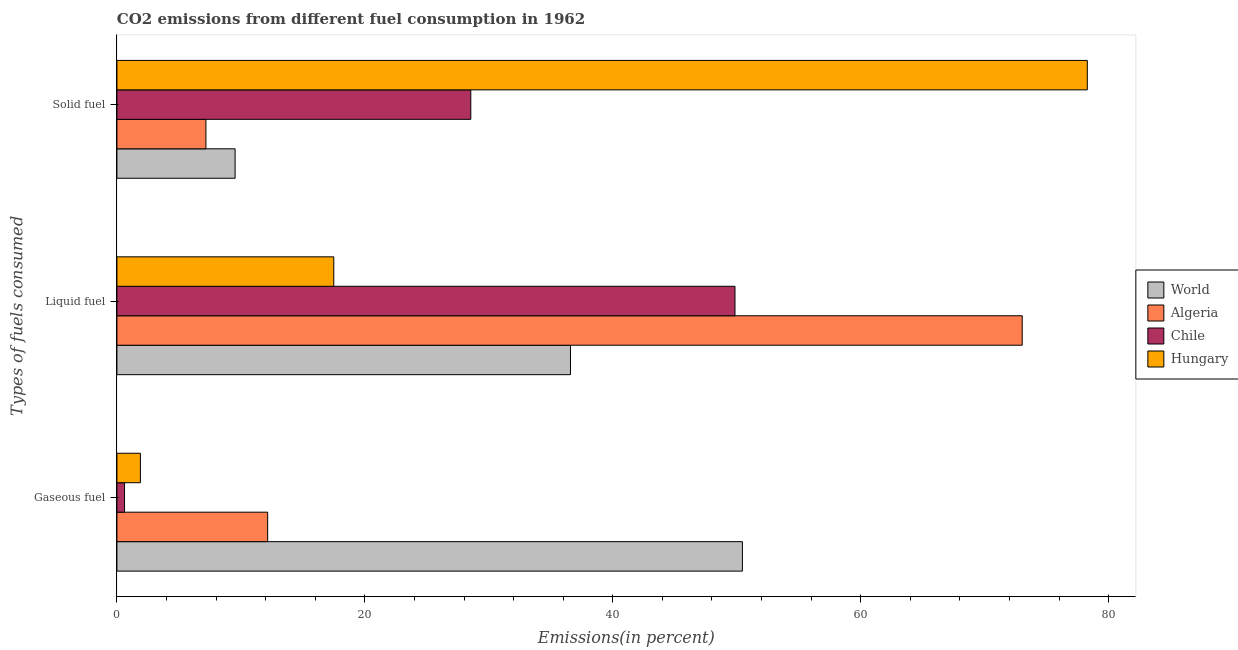Are the number of bars on each tick of the Y-axis equal?
Your response must be concise. Yes. How many bars are there on the 1st tick from the top?
Ensure brevity in your answer.  4. What is the label of the 2nd group of bars from the top?
Offer a terse response. Liquid fuel. What is the percentage of liquid fuel emission in World?
Your response must be concise. 36.59. Across all countries, what is the maximum percentage of gaseous fuel emission?
Provide a succinct answer. 50.46. Across all countries, what is the minimum percentage of liquid fuel emission?
Offer a terse response. 17.49. In which country was the percentage of solid fuel emission maximum?
Give a very brief answer. Hungary. In which country was the percentage of solid fuel emission minimum?
Your response must be concise. Algeria. What is the total percentage of gaseous fuel emission in the graph?
Your answer should be compact. 65.12. What is the difference between the percentage of solid fuel emission in Algeria and that in World?
Provide a short and direct response. -2.35. What is the difference between the percentage of gaseous fuel emission in Chile and the percentage of solid fuel emission in World?
Your response must be concise. -8.92. What is the average percentage of solid fuel emission per country?
Keep it short and to the point. 30.88. What is the difference between the percentage of gaseous fuel emission and percentage of solid fuel emission in Chile?
Make the answer very short. -27.93. What is the ratio of the percentage of solid fuel emission in World to that in Algeria?
Ensure brevity in your answer.  1.33. Is the difference between the percentage of gaseous fuel emission in Hungary and Chile greater than the difference between the percentage of solid fuel emission in Hungary and Chile?
Offer a terse response. No. What is the difference between the highest and the second highest percentage of solid fuel emission?
Your answer should be compact. 49.73. What is the difference between the highest and the lowest percentage of liquid fuel emission?
Give a very brief answer. 55.53. In how many countries, is the percentage of liquid fuel emission greater than the average percentage of liquid fuel emission taken over all countries?
Make the answer very short. 2. What does the 1st bar from the top in Gaseous fuel represents?
Make the answer very short. Hungary. What does the 2nd bar from the bottom in Gaseous fuel represents?
Your response must be concise. Algeria. How many bars are there?
Make the answer very short. 12. How many countries are there in the graph?
Your answer should be very brief. 4. What is the difference between two consecutive major ticks on the X-axis?
Ensure brevity in your answer.  20. Are the values on the major ticks of X-axis written in scientific E-notation?
Provide a short and direct response. No. How are the legend labels stacked?
Make the answer very short. Vertical. What is the title of the graph?
Keep it short and to the point. CO2 emissions from different fuel consumption in 1962. Does "Seychelles" appear as one of the legend labels in the graph?
Make the answer very short. No. What is the label or title of the X-axis?
Give a very brief answer. Emissions(in percent). What is the label or title of the Y-axis?
Keep it short and to the point. Types of fuels consumed. What is the Emissions(in percent) in World in Gaseous fuel?
Offer a terse response. 50.46. What is the Emissions(in percent) of Algeria in Gaseous fuel?
Provide a succinct answer. 12.16. What is the Emissions(in percent) of Chile in Gaseous fuel?
Keep it short and to the point. 0.61. What is the Emissions(in percent) in Hungary in Gaseous fuel?
Your answer should be very brief. 1.89. What is the Emissions(in percent) in World in Liquid fuel?
Your answer should be compact. 36.59. What is the Emissions(in percent) in Algeria in Liquid fuel?
Make the answer very short. 73.03. What is the Emissions(in percent) of Chile in Liquid fuel?
Your answer should be very brief. 49.86. What is the Emissions(in percent) in Hungary in Liquid fuel?
Offer a terse response. 17.49. What is the Emissions(in percent) of World in Solid fuel?
Ensure brevity in your answer.  9.53. What is the Emissions(in percent) of Algeria in Solid fuel?
Make the answer very short. 7.18. What is the Emissions(in percent) of Chile in Solid fuel?
Offer a terse response. 28.55. What is the Emissions(in percent) in Hungary in Solid fuel?
Your answer should be compact. 78.28. Across all Types of fuels consumed, what is the maximum Emissions(in percent) in World?
Offer a terse response. 50.46. Across all Types of fuels consumed, what is the maximum Emissions(in percent) of Algeria?
Your answer should be compact. 73.03. Across all Types of fuels consumed, what is the maximum Emissions(in percent) of Chile?
Your response must be concise. 49.86. Across all Types of fuels consumed, what is the maximum Emissions(in percent) in Hungary?
Offer a very short reply. 78.28. Across all Types of fuels consumed, what is the minimum Emissions(in percent) of World?
Provide a succinct answer. 9.53. Across all Types of fuels consumed, what is the minimum Emissions(in percent) of Algeria?
Your answer should be compact. 7.18. Across all Types of fuels consumed, what is the minimum Emissions(in percent) in Chile?
Offer a terse response. 0.61. Across all Types of fuels consumed, what is the minimum Emissions(in percent) in Hungary?
Provide a short and direct response. 1.89. What is the total Emissions(in percent) of World in the graph?
Your answer should be very brief. 96.58. What is the total Emissions(in percent) of Algeria in the graph?
Give a very brief answer. 92.37. What is the total Emissions(in percent) of Chile in the graph?
Your answer should be compact. 79.02. What is the total Emissions(in percent) in Hungary in the graph?
Ensure brevity in your answer.  97.66. What is the difference between the Emissions(in percent) in World in Gaseous fuel and that in Liquid fuel?
Offer a very short reply. 13.87. What is the difference between the Emissions(in percent) of Algeria in Gaseous fuel and that in Liquid fuel?
Keep it short and to the point. -60.87. What is the difference between the Emissions(in percent) of Chile in Gaseous fuel and that in Liquid fuel?
Ensure brevity in your answer.  -49.24. What is the difference between the Emissions(in percent) in Hungary in Gaseous fuel and that in Liquid fuel?
Provide a short and direct response. -15.6. What is the difference between the Emissions(in percent) in World in Gaseous fuel and that in Solid fuel?
Provide a short and direct response. 40.92. What is the difference between the Emissions(in percent) in Algeria in Gaseous fuel and that in Solid fuel?
Your answer should be compact. 4.98. What is the difference between the Emissions(in percent) in Chile in Gaseous fuel and that in Solid fuel?
Provide a succinct answer. -27.93. What is the difference between the Emissions(in percent) in Hungary in Gaseous fuel and that in Solid fuel?
Your answer should be compact. -76.39. What is the difference between the Emissions(in percent) in World in Liquid fuel and that in Solid fuel?
Give a very brief answer. 27.05. What is the difference between the Emissions(in percent) of Algeria in Liquid fuel and that in Solid fuel?
Keep it short and to the point. 65.85. What is the difference between the Emissions(in percent) of Chile in Liquid fuel and that in Solid fuel?
Your answer should be compact. 21.31. What is the difference between the Emissions(in percent) in Hungary in Liquid fuel and that in Solid fuel?
Your answer should be compact. -60.78. What is the difference between the Emissions(in percent) in World in Gaseous fuel and the Emissions(in percent) in Algeria in Liquid fuel?
Offer a very short reply. -22.57. What is the difference between the Emissions(in percent) of World in Gaseous fuel and the Emissions(in percent) of Chile in Liquid fuel?
Your answer should be very brief. 0.6. What is the difference between the Emissions(in percent) of World in Gaseous fuel and the Emissions(in percent) of Hungary in Liquid fuel?
Give a very brief answer. 32.96. What is the difference between the Emissions(in percent) of Algeria in Gaseous fuel and the Emissions(in percent) of Chile in Liquid fuel?
Ensure brevity in your answer.  -37.7. What is the difference between the Emissions(in percent) of Algeria in Gaseous fuel and the Emissions(in percent) of Hungary in Liquid fuel?
Your answer should be very brief. -5.33. What is the difference between the Emissions(in percent) of Chile in Gaseous fuel and the Emissions(in percent) of Hungary in Liquid fuel?
Provide a short and direct response. -16.88. What is the difference between the Emissions(in percent) of World in Gaseous fuel and the Emissions(in percent) of Algeria in Solid fuel?
Give a very brief answer. 43.28. What is the difference between the Emissions(in percent) in World in Gaseous fuel and the Emissions(in percent) in Chile in Solid fuel?
Offer a very short reply. 21.91. What is the difference between the Emissions(in percent) in World in Gaseous fuel and the Emissions(in percent) in Hungary in Solid fuel?
Ensure brevity in your answer.  -27.82. What is the difference between the Emissions(in percent) of Algeria in Gaseous fuel and the Emissions(in percent) of Chile in Solid fuel?
Ensure brevity in your answer.  -16.39. What is the difference between the Emissions(in percent) in Algeria in Gaseous fuel and the Emissions(in percent) in Hungary in Solid fuel?
Ensure brevity in your answer.  -66.12. What is the difference between the Emissions(in percent) in Chile in Gaseous fuel and the Emissions(in percent) in Hungary in Solid fuel?
Your answer should be compact. -77.66. What is the difference between the Emissions(in percent) of World in Liquid fuel and the Emissions(in percent) of Algeria in Solid fuel?
Give a very brief answer. 29.41. What is the difference between the Emissions(in percent) of World in Liquid fuel and the Emissions(in percent) of Chile in Solid fuel?
Your response must be concise. 8.04. What is the difference between the Emissions(in percent) of World in Liquid fuel and the Emissions(in percent) of Hungary in Solid fuel?
Make the answer very short. -41.69. What is the difference between the Emissions(in percent) of Algeria in Liquid fuel and the Emissions(in percent) of Chile in Solid fuel?
Provide a succinct answer. 44.48. What is the difference between the Emissions(in percent) in Algeria in Liquid fuel and the Emissions(in percent) in Hungary in Solid fuel?
Your answer should be compact. -5.25. What is the difference between the Emissions(in percent) in Chile in Liquid fuel and the Emissions(in percent) in Hungary in Solid fuel?
Make the answer very short. -28.42. What is the average Emissions(in percent) of World per Types of fuels consumed?
Make the answer very short. 32.19. What is the average Emissions(in percent) of Algeria per Types of fuels consumed?
Your response must be concise. 30.79. What is the average Emissions(in percent) of Chile per Types of fuels consumed?
Provide a short and direct response. 26.34. What is the average Emissions(in percent) in Hungary per Types of fuels consumed?
Give a very brief answer. 32.55. What is the difference between the Emissions(in percent) in World and Emissions(in percent) in Algeria in Gaseous fuel?
Make the answer very short. 38.29. What is the difference between the Emissions(in percent) in World and Emissions(in percent) in Chile in Gaseous fuel?
Make the answer very short. 49.84. What is the difference between the Emissions(in percent) of World and Emissions(in percent) of Hungary in Gaseous fuel?
Your answer should be very brief. 48.56. What is the difference between the Emissions(in percent) in Algeria and Emissions(in percent) in Chile in Gaseous fuel?
Your response must be concise. 11.55. What is the difference between the Emissions(in percent) in Algeria and Emissions(in percent) in Hungary in Gaseous fuel?
Give a very brief answer. 10.27. What is the difference between the Emissions(in percent) in Chile and Emissions(in percent) in Hungary in Gaseous fuel?
Offer a very short reply. -1.28. What is the difference between the Emissions(in percent) in World and Emissions(in percent) in Algeria in Liquid fuel?
Your answer should be very brief. -36.44. What is the difference between the Emissions(in percent) in World and Emissions(in percent) in Chile in Liquid fuel?
Keep it short and to the point. -13.27. What is the difference between the Emissions(in percent) in World and Emissions(in percent) in Hungary in Liquid fuel?
Your response must be concise. 19.09. What is the difference between the Emissions(in percent) in Algeria and Emissions(in percent) in Chile in Liquid fuel?
Your answer should be compact. 23.17. What is the difference between the Emissions(in percent) of Algeria and Emissions(in percent) of Hungary in Liquid fuel?
Your answer should be compact. 55.53. What is the difference between the Emissions(in percent) of Chile and Emissions(in percent) of Hungary in Liquid fuel?
Your answer should be compact. 32.36. What is the difference between the Emissions(in percent) of World and Emissions(in percent) of Algeria in Solid fuel?
Your response must be concise. 2.35. What is the difference between the Emissions(in percent) of World and Emissions(in percent) of Chile in Solid fuel?
Ensure brevity in your answer.  -19.01. What is the difference between the Emissions(in percent) in World and Emissions(in percent) in Hungary in Solid fuel?
Your response must be concise. -68.74. What is the difference between the Emissions(in percent) of Algeria and Emissions(in percent) of Chile in Solid fuel?
Offer a very short reply. -21.37. What is the difference between the Emissions(in percent) in Algeria and Emissions(in percent) in Hungary in Solid fuel?
Ensure brevity in your answer.  -71.1. What is the difference between the Emissions(in percent) of Chile and Emissions(in percent) of Hungary in Solid fuel?
Offer a very short reply. -49.73. What is the ratio of the Emissions(in percent) in World in Gaseous fuel to that in Liquid fuel?
Your answer should be compact. 1.38. What is the ratio of the Emissions(in percent) in Algeria in Gaseous fuel to that in Liquid fuel?
Make the answer very short. 0.17. What is the ratio of the Emissions(in percent) in Chile in Gaseous fuel to that in Liquid fuel?
Your response must be concise. 0.01. What is the ratio of the Emissions(in percent) of Hungary in Gaseous fuel to that in Liquid fuel?
Provide a short and direct response. 0.11. What is the ratio of the Emissions(in percent) in World in Gaseous fuel to that in Solid fuel?
Give a very brief answer. 5.29. What is the ratio of the Emissions(in percent) of Algeria in Gaseous fuel to that in Solid fuel?
Your answer should be compact. 1.69. What is the ratio of the Emissions(in percent) in Chile in Gaseous fuel to that in Solid fuel?
Offer a terse response. 0.02. What is the ratio of the Emissions(in percent) of Hungary in Gaseous fuel to that in Solid fuel?
Provide a short and direct response. 0.02. What is the ratio of the Emissions(in percent) in World in Liquid fuel to that in Solid fuel?
Give a very brief answer. 3.84. What is the ratio of the Emissions(in percent) of Algeria in Liquid fuel to that in Solid fuel?
Offer a terse response. 10.17. What is the ratio of the Emissions(in percent) in Chile in Liquid fuel to that in Solid fuel?
Give a very brief answer. 1.75. What is the ratio of the Emissions(in percent) in Hungary in Liquid fuel to that in Solid fuel?
Give a very brief answer. 0.22. What is the difference between the highest and the second highest Emissions(in percent) in World?
Offer a very short reply. 13.87. What is the difference between the highest and the second highest Emissions(in percent) of Algeria?
Offer a very short reply. 60.87. What is the difference between the highest and the second highest Emissions(in percent) of Chile?
Offer a terse response. 21.31. What is the difference between the highest and the second highest Emissions(in percent) of Hungary?
Keep it short and to the point. 60.78. What is the difference between the highest and the lowest Emissions(in percent) in World?
Your response must be concise. 40.92. What is the difference between the highest and the lowest Emissions(in percent) in Algeria?
Keep it short and to the point. 65.85. What is the difference between the highest and the lowest Emissions(in percent) of Chile?
Your response must be concise. 49.24. What is the difference between the highest and the lowest Emissions(in percent) in Hungary?
Keep it short and to the point. 76.39. 